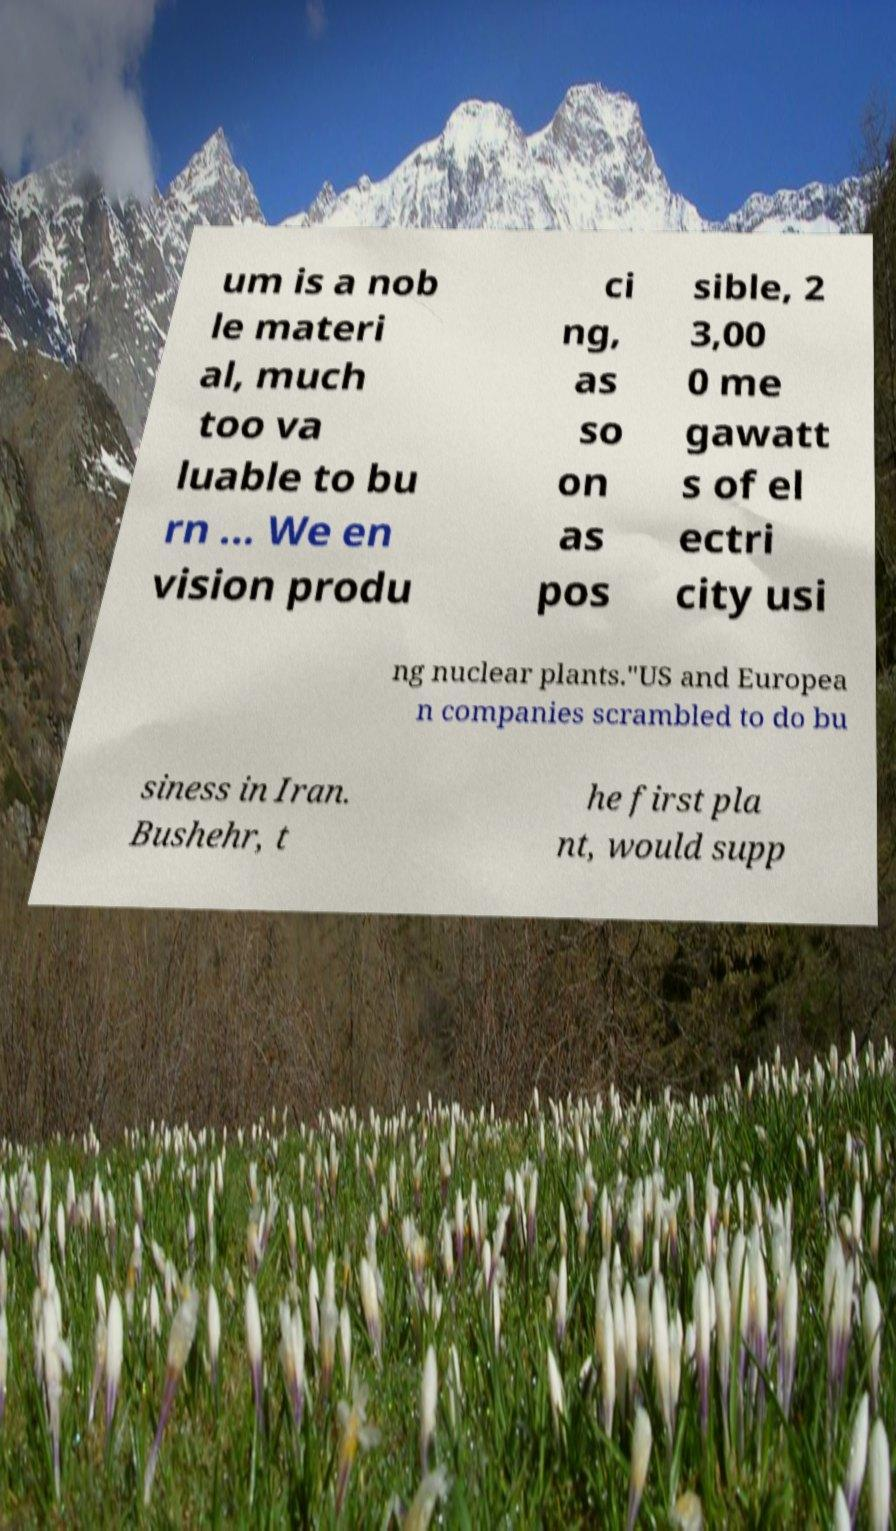For documentation purposes, I need the text within this image transcribed. Could you provide that? um is a nob le materi al, much too va luable to bu rn ... We en vision produ ci ng, as so on as pos sible, 2 3,00 0 me gawatt s of el ectri city usi ng nuclear plants."US and Europea n companies scrambled to do bu siness in Iran. Bushehr, t he first pla nt, would supp 